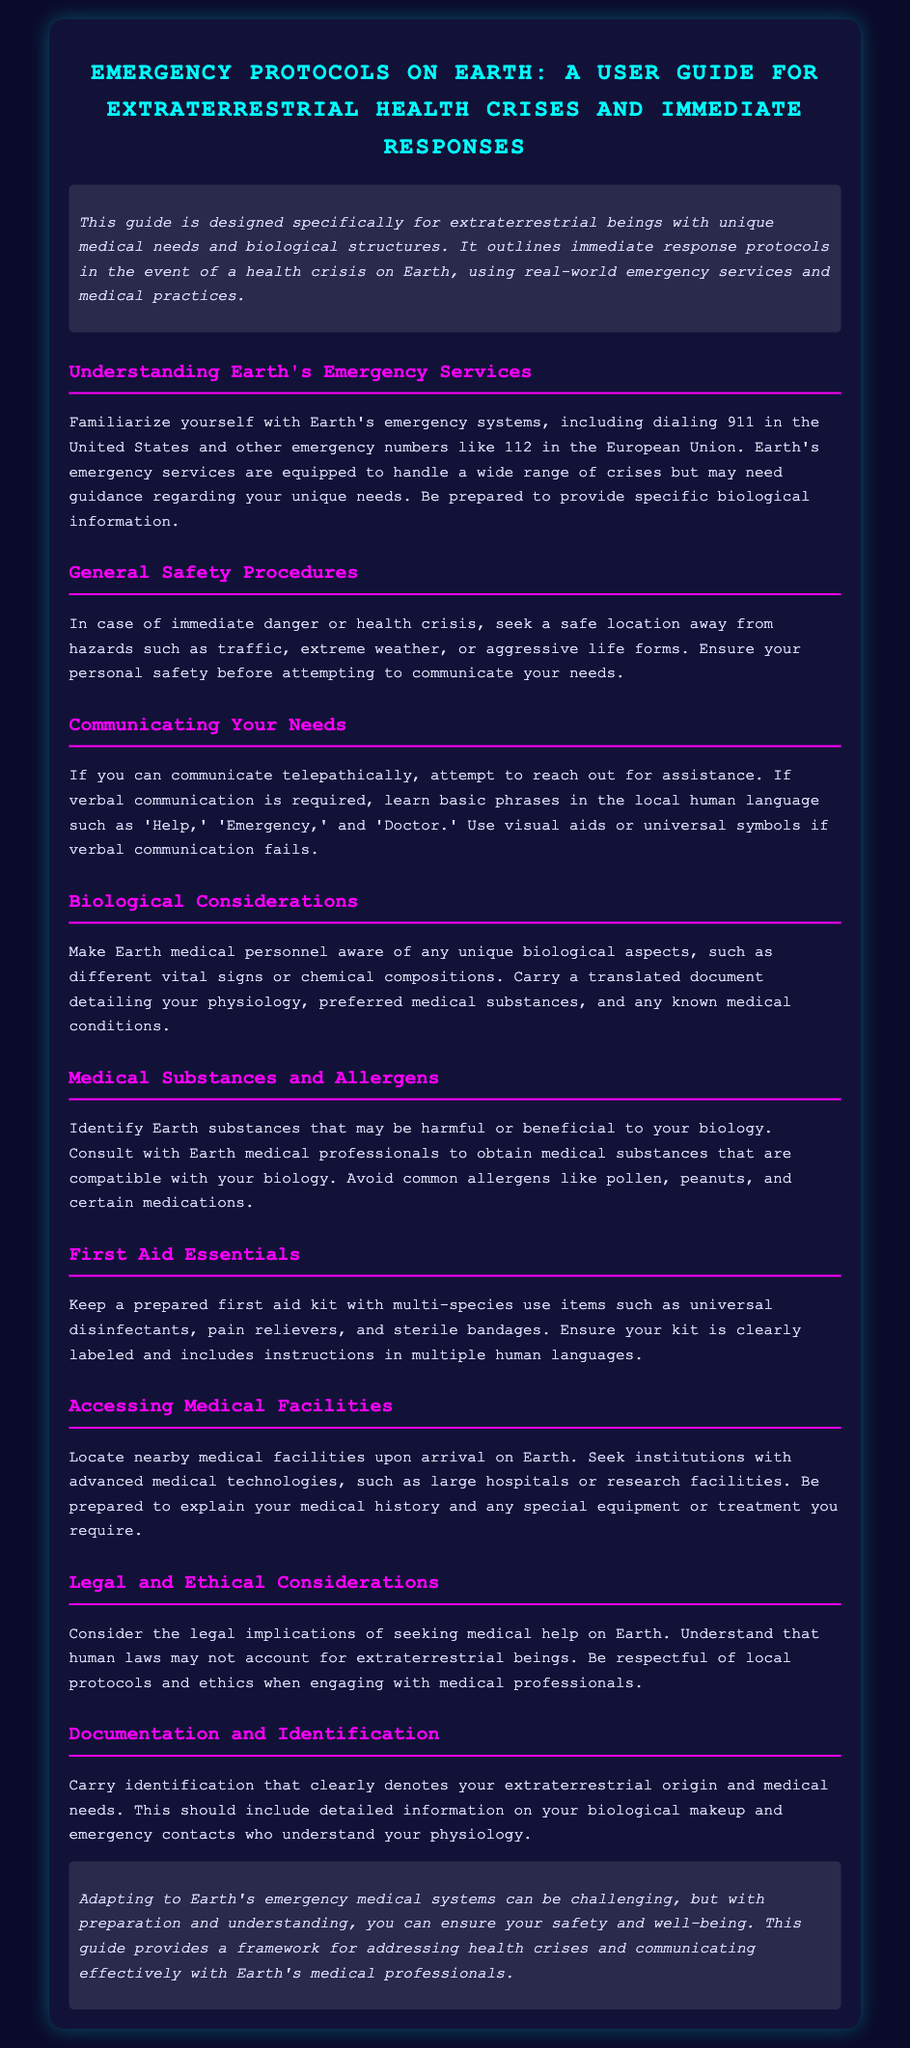What is the title of the document? The title of the document is found prominently at the top and indicates its main subject.
Answer: Emergency Protocols on Earth: A User Guide for Extraterrestrial Health Crises and Immediate Responses What is the emergency number in the United States? The emergency number specific to the United States is mentioned in the section about emergency services.
Answer: 911 What should you carry to help communicate your biological needs? The document mentions a specific type of document that would assist in communication and understanding of your biology.
Answer: Translated document Which allergens should be avoided according to the guide? The guide lists common allergens that extraterrestrial beings may need to be cautious of.
Answer: Pollen, peanuts, certain medications What essential item should be included in a first aid kit? The document provides examples of items that should be in the first aid kit for multi-species use.
Answer: Universal disinfectants How should you access medical facilities on Earth? The guide elaborates on specific institutions that would be preferable for accessing medical care.
Answer: Large hospitals or research facilities What is a potential legal consideration when seeking medical help? The document mentions a specific aspect of the law that extraterrestrial beings should keep in mind.
Answer: Legal implications What type of communication method is suggested if telepathy is possible? The guide suggests a method of communication for those who can use a certain ability.
Answer: Reach out for assistance What color is the background of the document? The design of the document includes a specific color scheme that sets the tone of the presentation.
Answer: Dark blue 